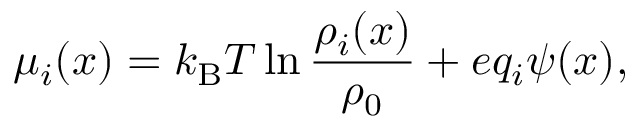Convert formula to latex. <formula><loc_0><loc_0><loc_500><loc_500>\mu _ { i } ( x ) = k _ { B } T \ln \frac { \rho _ { i } ( x ) } { \rho _ { 0 } } + e q _ { i } \psi ( x ) ,</formula> 